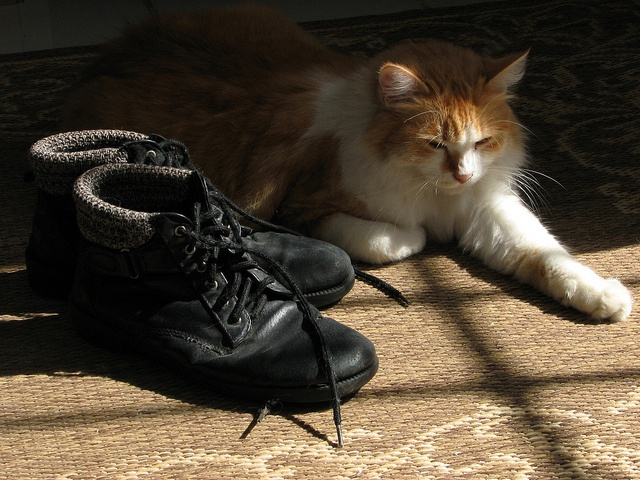Describe the objects in this image and their specific colors. I can see a cat in black, gray, and maroon tones in this image. 